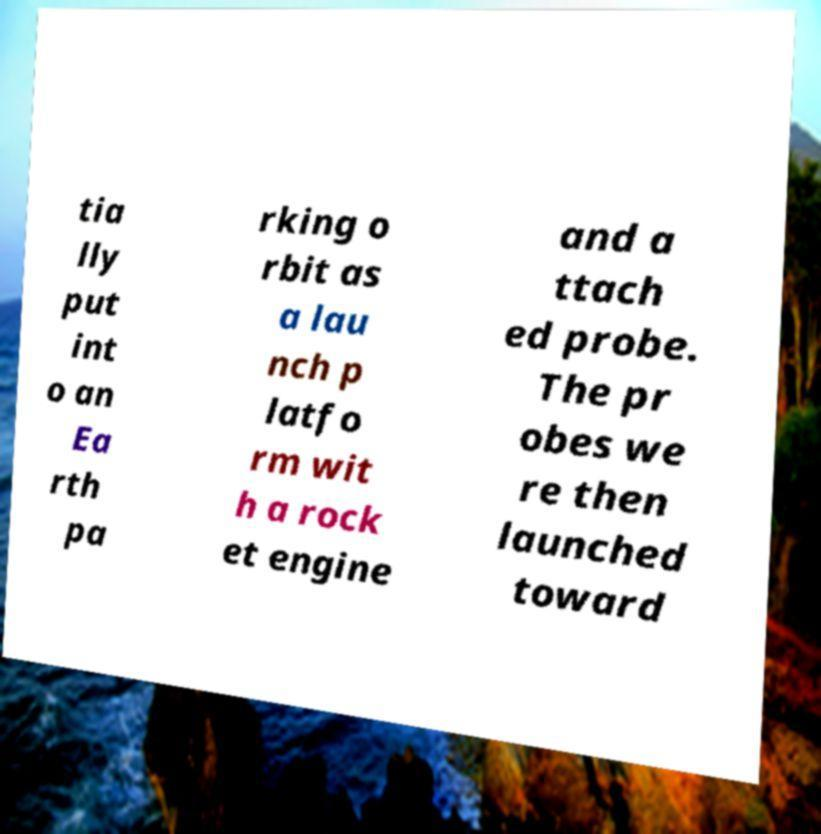Can you read and provide the text displayed in the image?This photo seems to have some interesting text. Can you extract and type it out for me? tia lly put int o an Ea rth pa rking o rbit as a lau nch p latfo rm wit h a rock et engine and a ttach ed probe. The pr obes we re then launched toward 